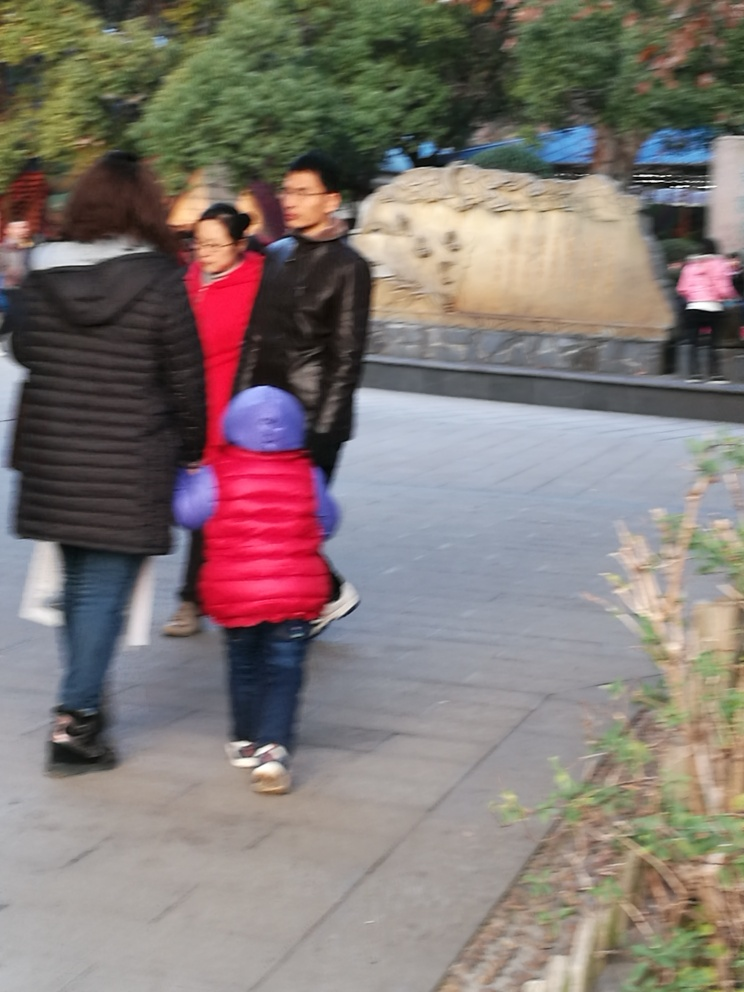Can you tell what time of day it might be based on the lighting in this image? The lighting in the image suggests that it might be late afternoon or early evening. The softness of the light, combined with the long shadows, often indicates that the sun is positioned lower in the sky, which is characteristic of those times of day. 